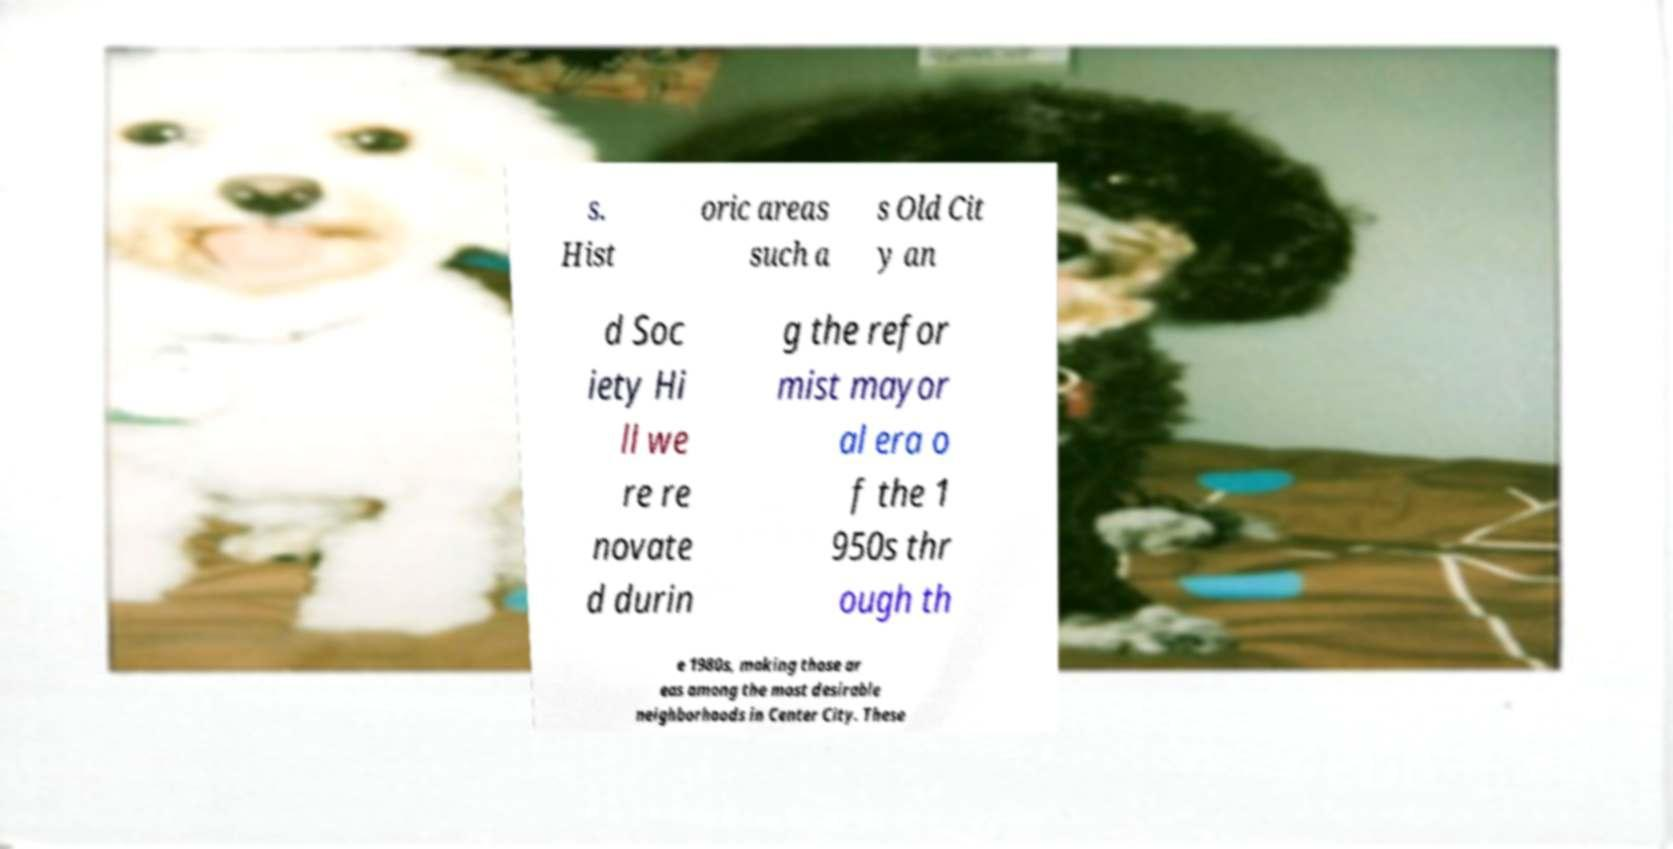Could you extract and type out the text from this image? s. Hist oric areas such a s Old Cit y an d Soc iety Hi ll we re re novate d durin g the refor mist mayor al era o f the 1 950s thr ough th e 1980s, making those ar eas among the most desirable neighborhoods in Center City. These 